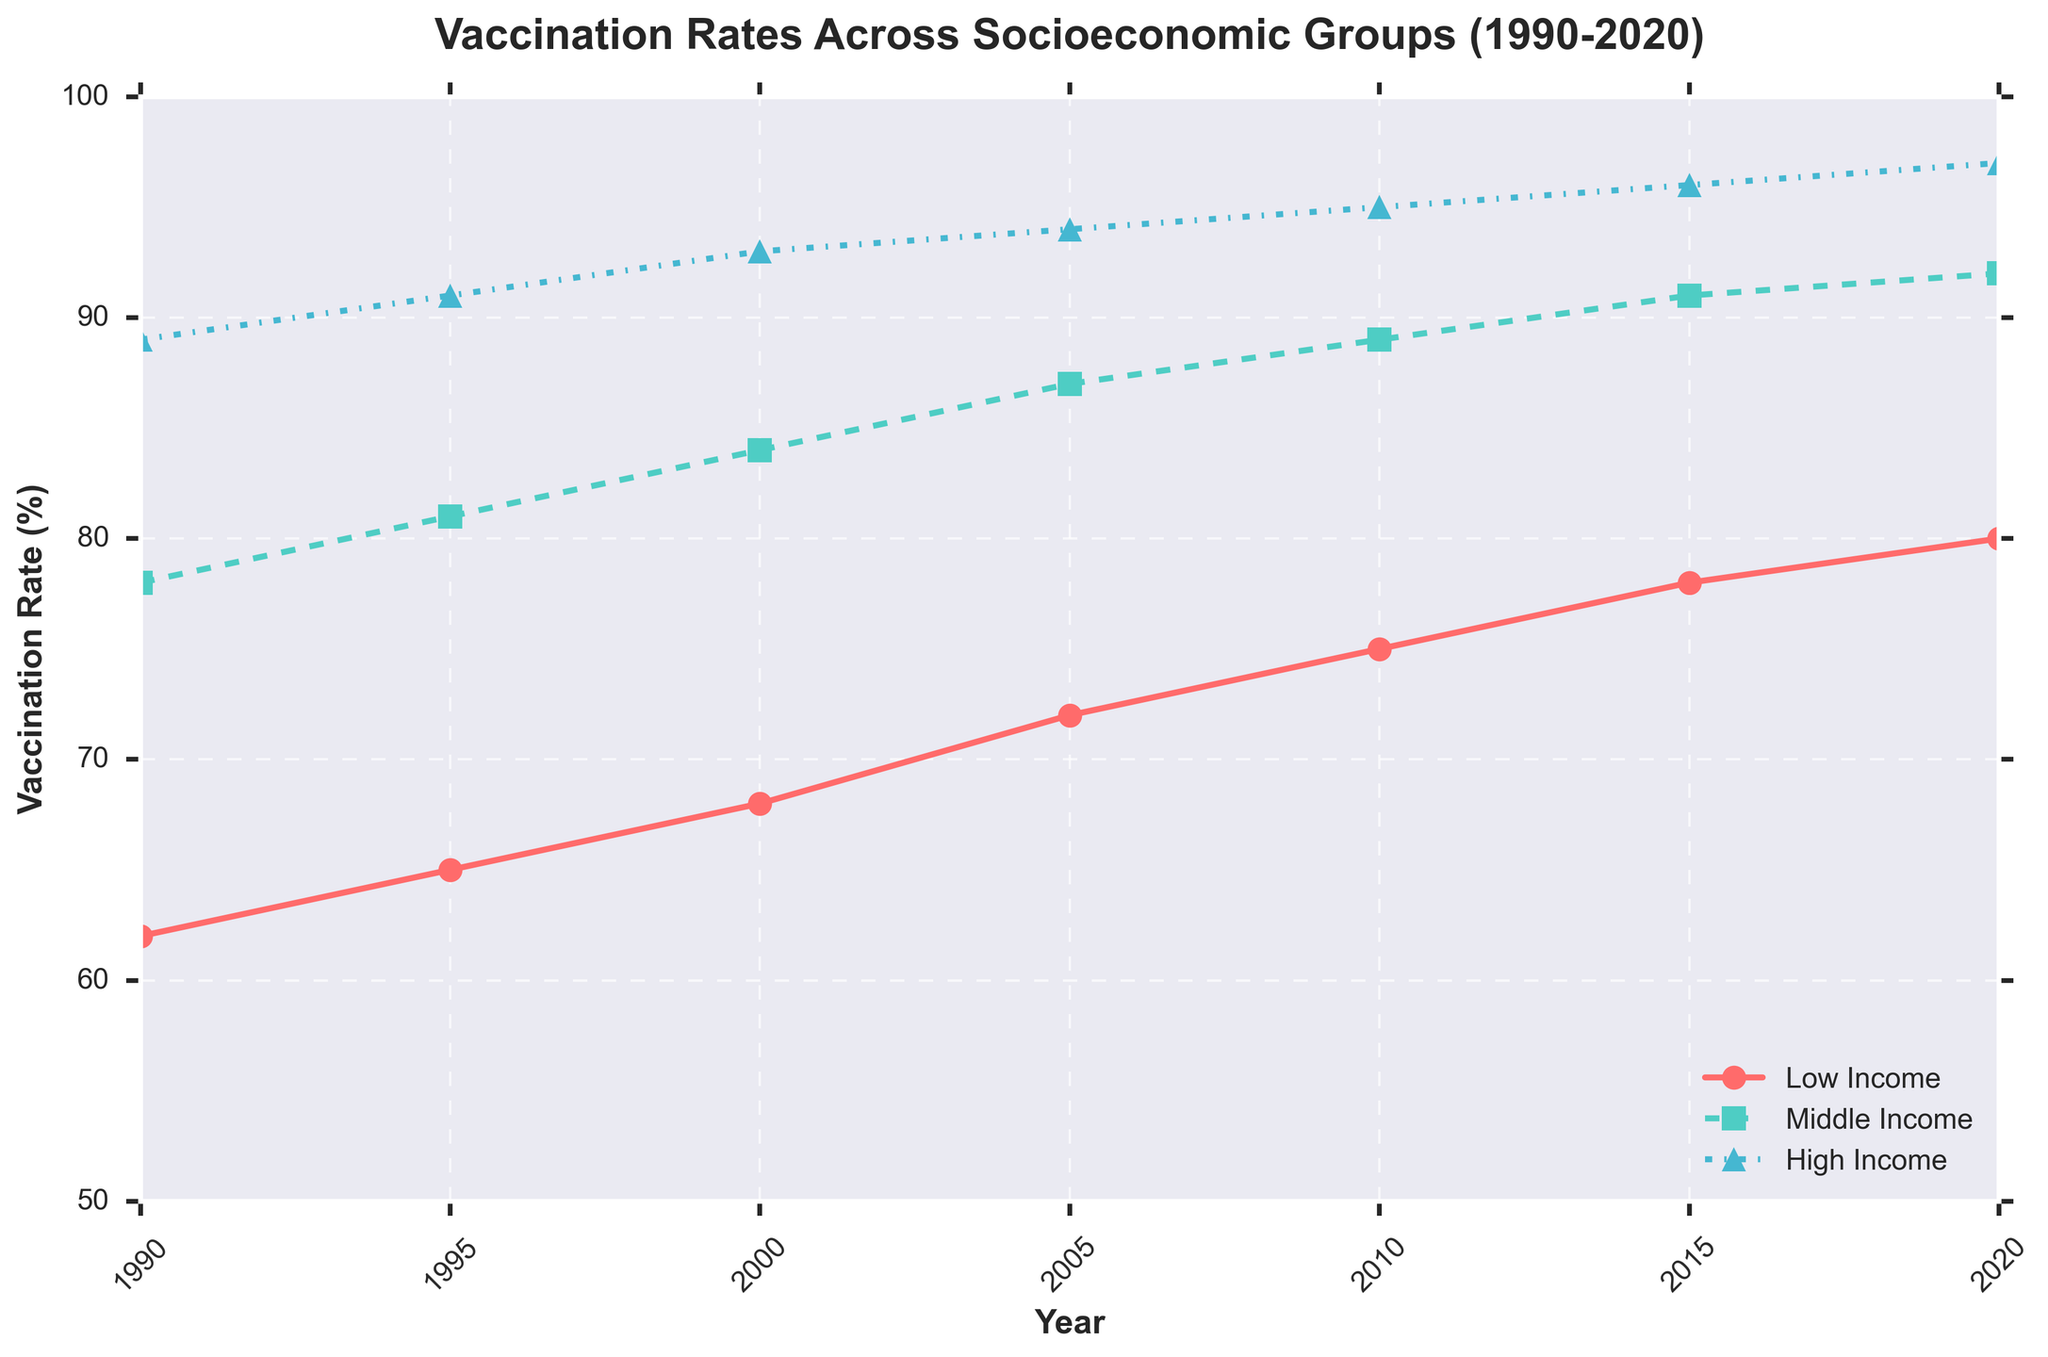What is the vaccination rate for high-income groups in 2010? Locate the year 2010 on the x-axis, and then find the corresponding point for the high-income group (marked with a triangle). The y-axis value at this point indicates the vaccination rate.
Answer: 95 Which socioeconomic group had the lowest vaccination rate in 1995? Identify the year 1995 on the x-axis. Compare the y-values of the points for low-income (red), middle-income (green), and high-income (blue) groups.
Answer: Low Income How much did the vaccination rate for middle-income groups increase from 1990 to 2020? For the middle-income group (green squares), find the values in 1990 and 2020. Calculate the difference: 92 (2020) - 78 (1990).
Answer: 14 Which socioeconomic group showed the highest increase in vaccination rates from 1990 to 2020? Calculate the increase for each group by subtracting the value in 1990 from the value in 2020: Low Income (80-62), Middle Income (92-78), High Income (97-89). Compare the increases.
Answer: Low Income Did the vaccination rates for all socioeconomic groups converge or diverge over time? Observe the trend lines for each group from 1990 to 2020. If the lines get closer together, they converge; if they separate further, they diverge.
Answer: Converge What is the overall trend in vaccination rates for low-income groups from 1990 to 2020? Follow the red line from 1990 to 2020. The direction of the line indicates the trend.
Answer: Increasing By how much did the vaccination rate for high-income groups increase between 2000 and 2010? Identify the y-values for high-income groups (blue triangles) in 2000 and 2010, then find the difference: 95 (2010) - 93 (2000).
Answer: 2 Which year showed the smallest difference in vaccination rates between middle and high-income groups? For each year, calculate the difference between the middle-income (green squares) and high-income (blue triangles) y-values. Find the year with the smallest difference.
Answer: 2020 In which year did the low-income group's vaccination rate first reach (or exceed) 70%? Follow the red line representing the low-income group's vaccination rate and identify the first year where the y-value is 70 or above.
Answer: 2005 Which group had the most stable vaccination rate over the years, indicated by the smoothest curve? Compare the lines' smoothness for each group from 1990 to 2020. The group with the least variation in trend is the most stable.
Answer: High Income 